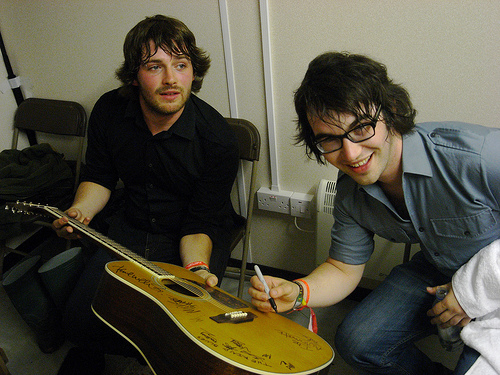<image>
Is the guitar on the knee? No. The guitar is not positioned on the knee. They may be near each other, but the guitar is not supported by or resting on top of the knee. Where is the man in relation to the guitar? Is it above the guitar? Yes. The man is positioned above the guitar in the vertical space, higher up in the scene. 